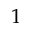<formula> <loc_0><loc_0><loc_500><loc_500>1</formula> 